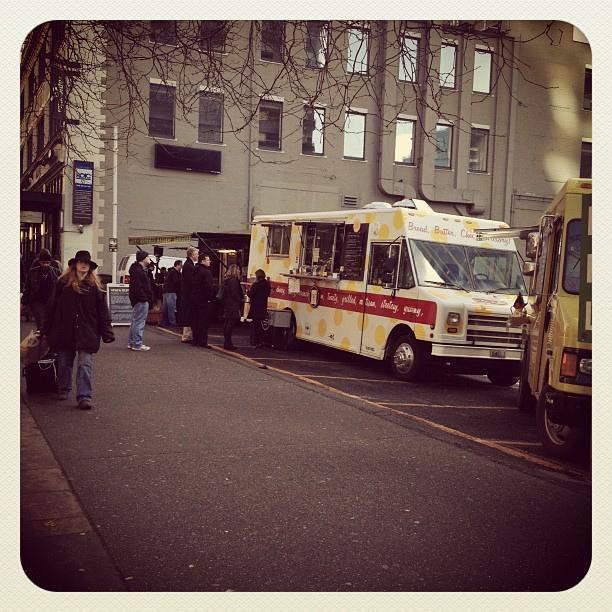How many beams are on the ceiling?
Give a very brief answer. 0. How many trucks can you see?
Give a very brief answer. 2. How many people can you see?
Give a very brief answer. 2. 